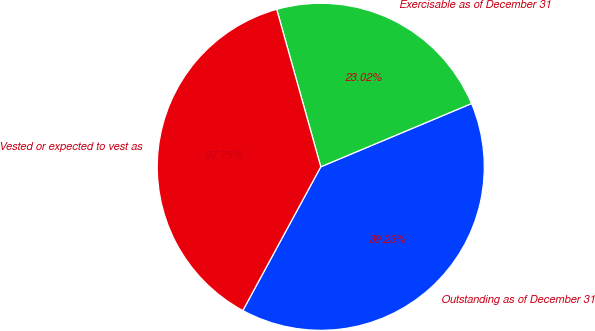<chart> <loc_0><loc_0><loc_500><loc_500><pie_chart><fcel>Outstanding as of December 31<fcel>Exercisable as of December 31<fcel>Vested or expected to vest as<nl><fcel>39.23%<fcel>23.02%<fcel>37.75%<nl></chart> 